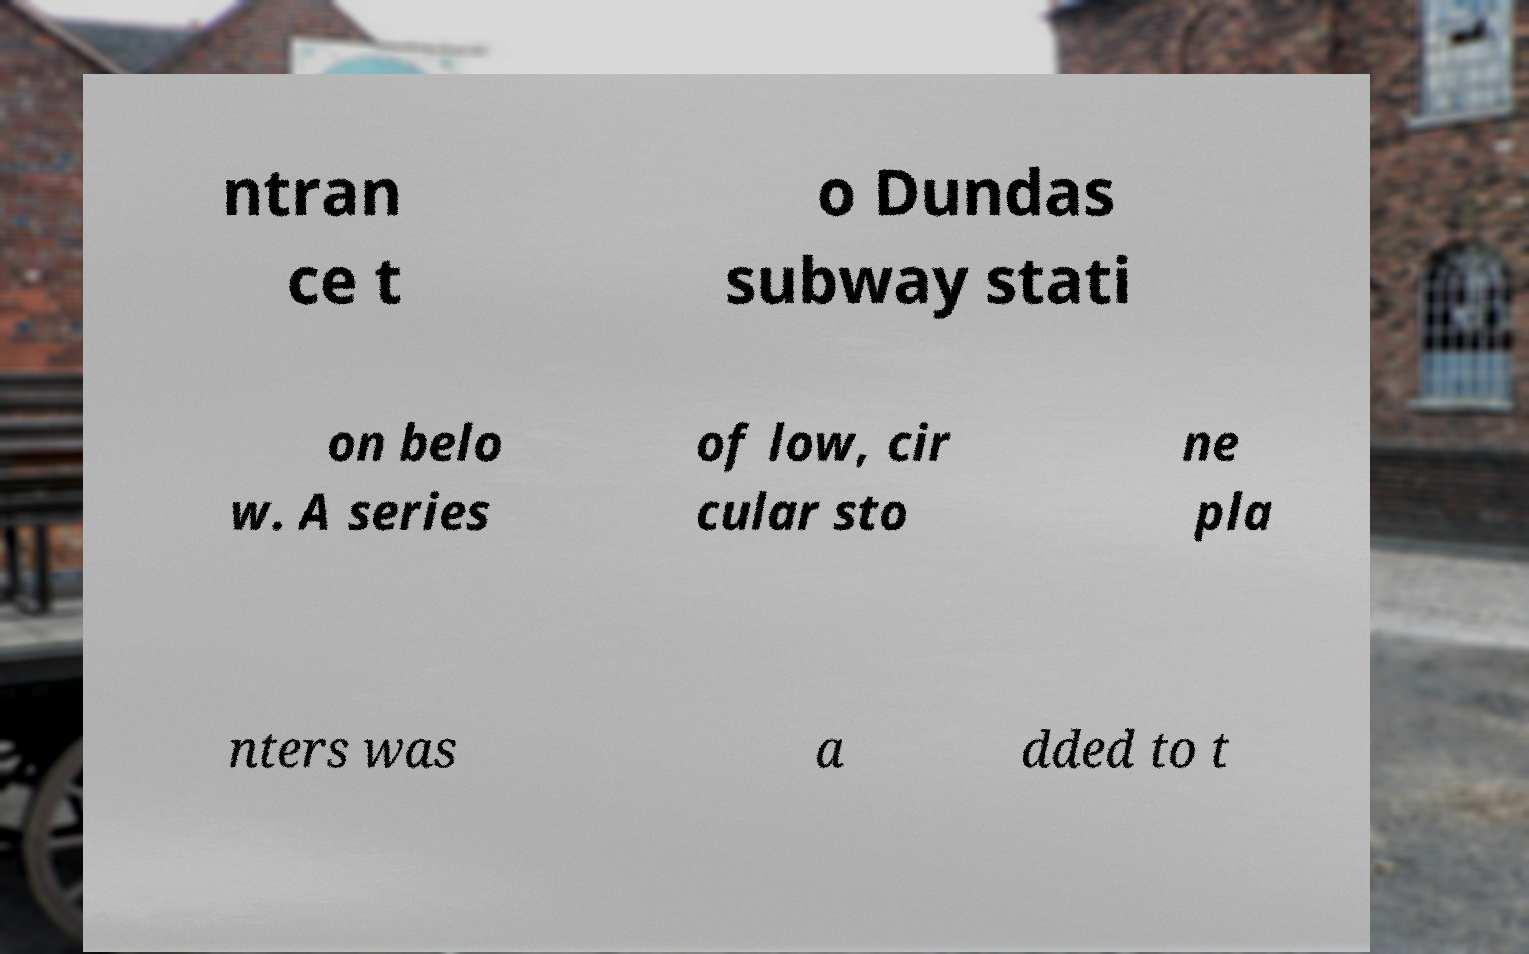Could you extract and type out the text from this image? ntran ce t o Dundas subway stati on belo w. A series of low, cir cular sto ne pla nters was a dded to t 